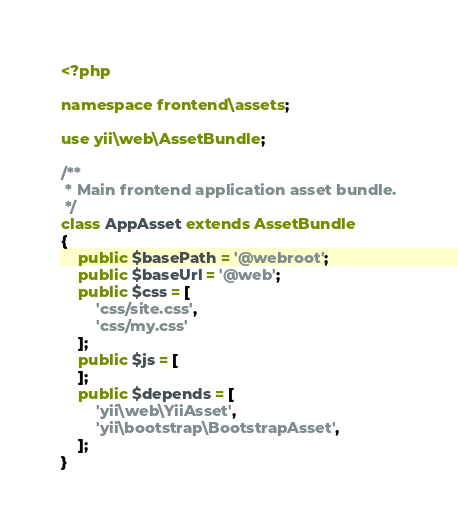Convert code to text. <code><loc_0><loc_0><loc_500><loc_500><_PHP_><?php

namespace frontend\assets;

use yii\web\AssetBundle;

/**
 * Main frontend application asset bundle.
 */
class AppAsset extends AssetBundle
{
    public $basePath = '@webroot';
    public $baseUrl = '@web';
    public $css = [
        'css/site.css',
        'css/my.css'
    ];
    public $js = [
    ];
    public $depends = [
        'yii\web\YiiAsset',
        'yii\bootstrap\BootstrapAsset',
    ];
}
</code> 